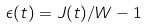<formula> <loc_0><loc_0><loc_500><loc_500>\epsilon ( t ) = { J ( t ) / W } - 1</formula> 